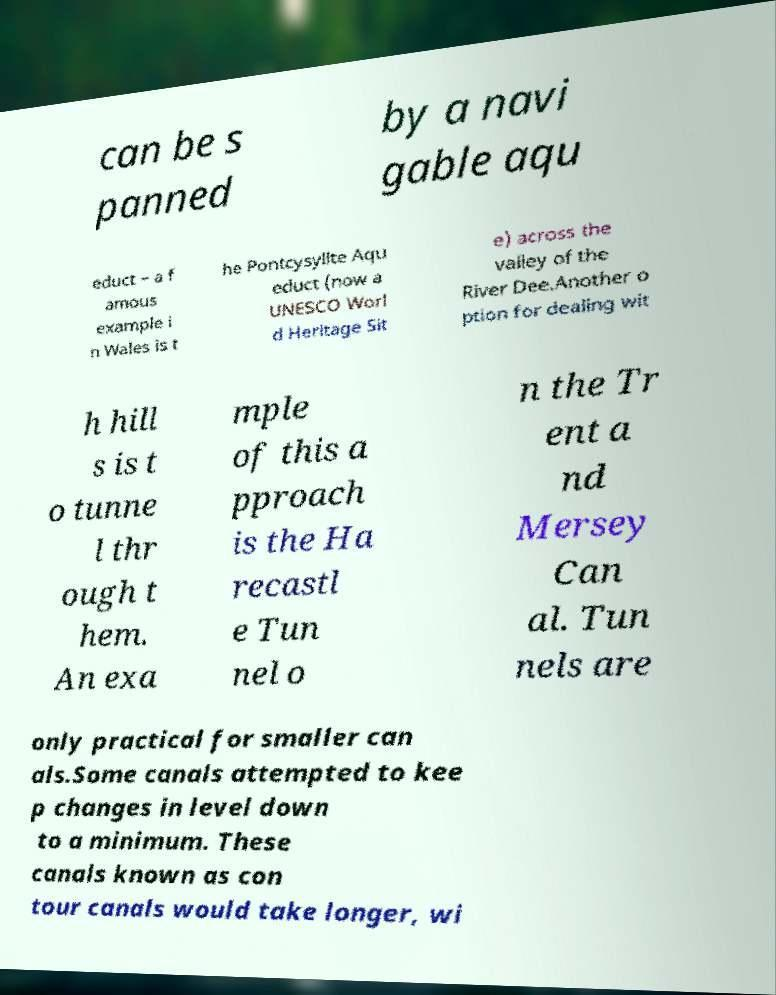For documentation purposes, I need the text within this image transcribed. Could you provide that? can be s panned by a navi gable aqu educt – a f amous example i n Wales is t he Pontcysyllte Aqu educt (now a UNESCO Worl d Heritage Sit e) across the valley of the River Dee.Another o ption for dealing wit h hill s is t o tunne l thr ough t hem. An exa mple of this a pproach is the Ha recastl e Tun nel o n the Tr ent a nd Mersey Can al. Tun nels are only practical for smaller can als.Some canals attempted to kee p changes in level down to a minimum. These canals known as con tour canals would take longer, wi 